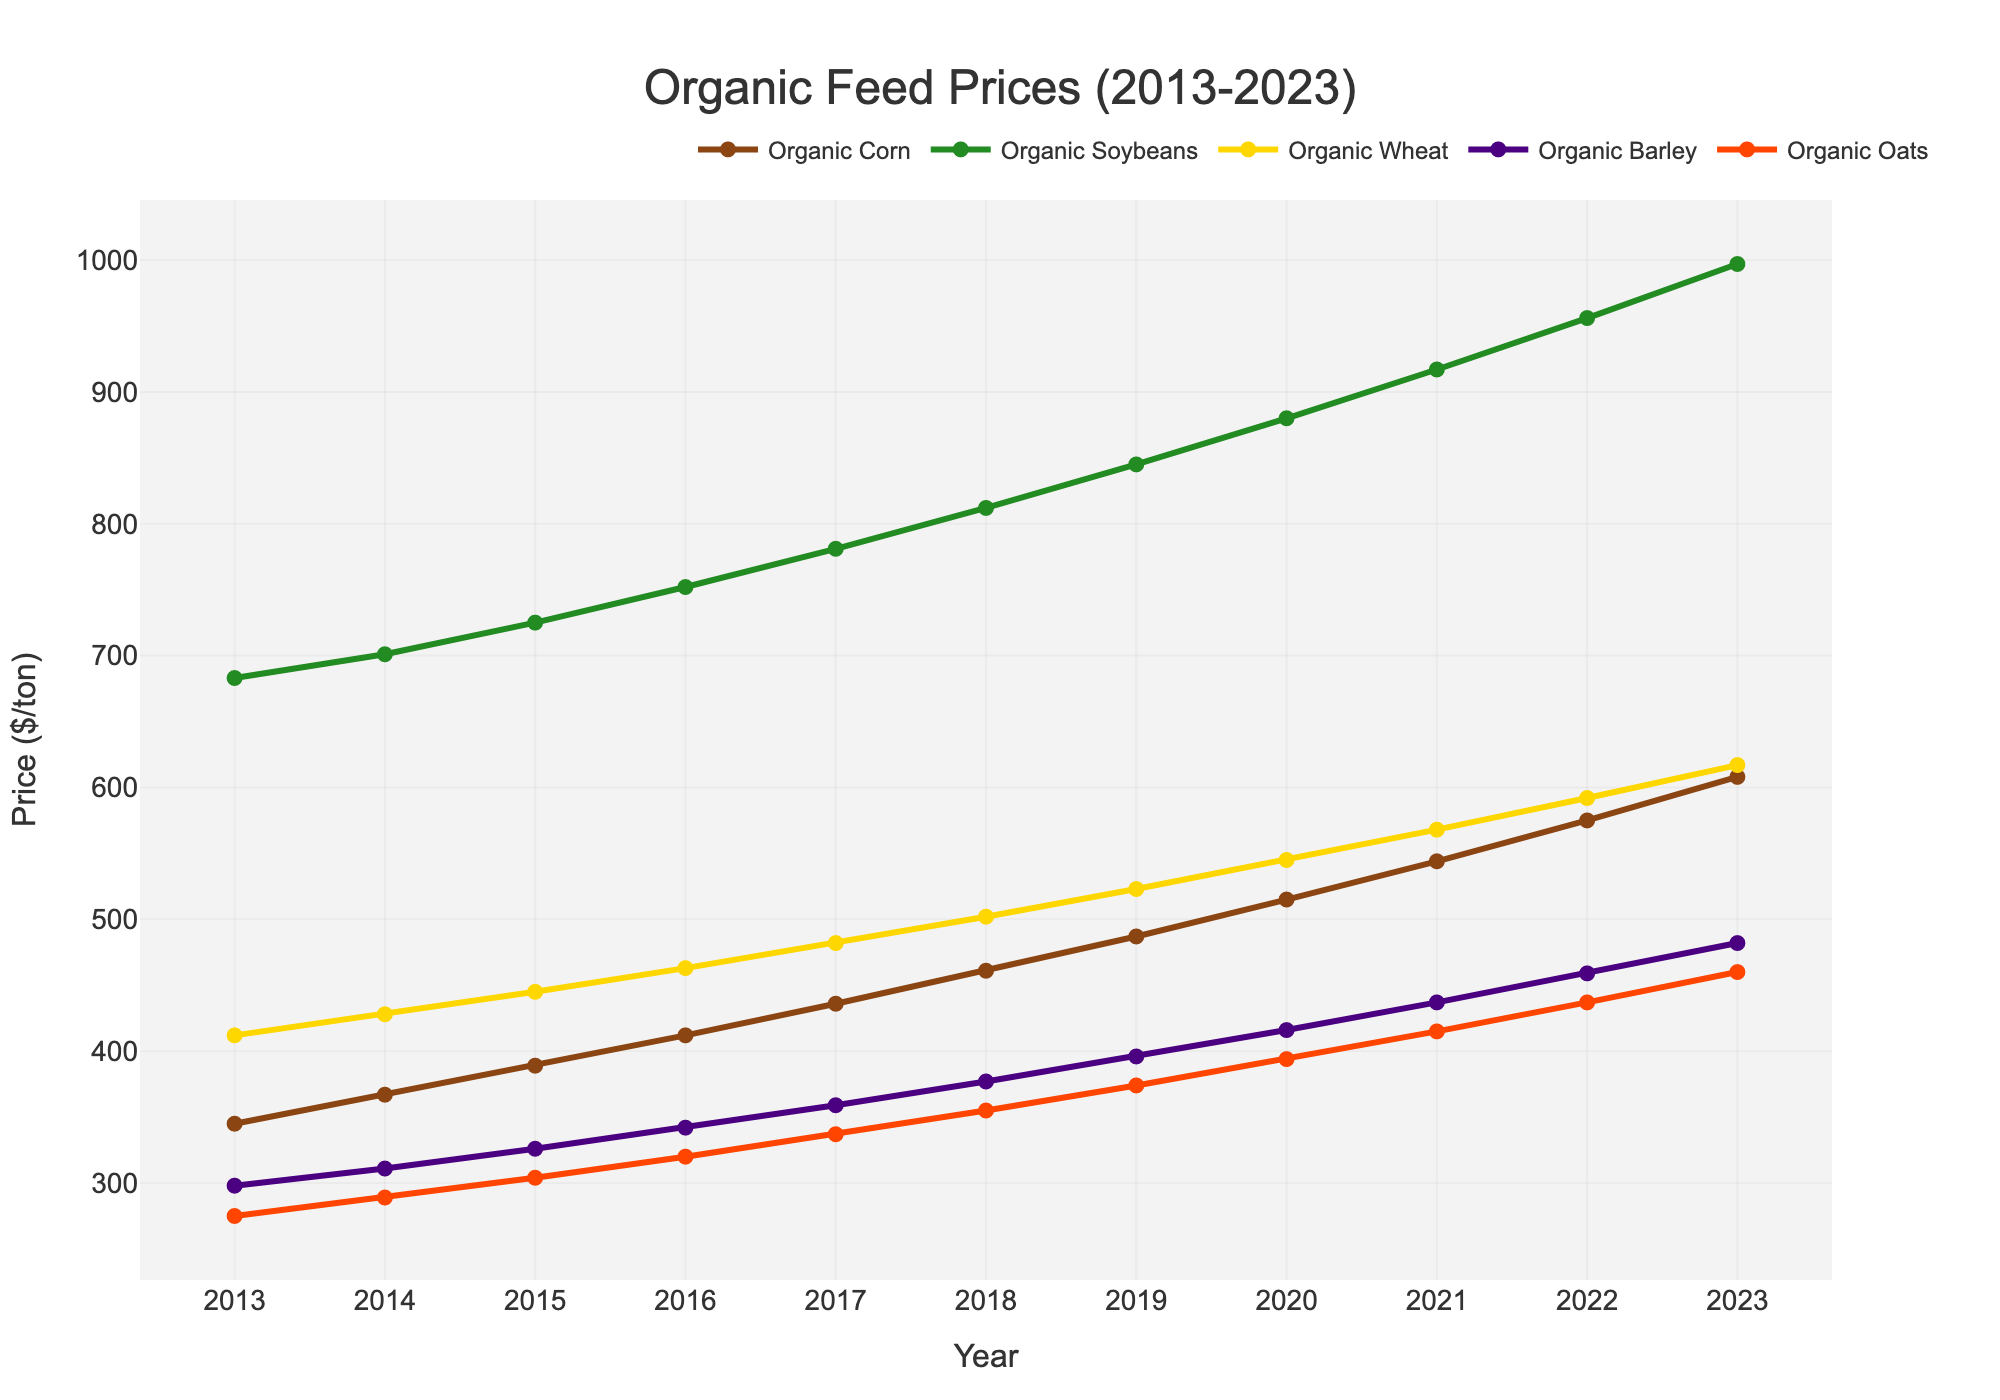What's the trend in Organic Corn prices from 2013 to 2023? To find the trend, observe the line representing Organic Corn. It starts at $345 in 2013 and steadily increases each year, reaching $608 in 2023. Thus, the trend shows a consistent rise in prices.
Answer: Consistent rise Which grain had the highest price in 2023? Look at the values for each grain in 2023: Organic Corn ($608), Organic Soybeans ($997), Organic Wheat ($617), Organic Barley ($482), and Organic Oats ($460). Organic Soybeans have the highest price at $997.
Answer: Organic Soybeans Calculate the average price of Organic Wheat from 2018 to 2023. Take the values of Organic Wheat from 2018 to 2023: 502, 523, 545, 568, 592, 617. Sum these values: 502 + 523 + 545 + 568 + 592 + 617 = 3347. Divide by the number of years, which is 6. So, the average price = 3347 / 6 ≈ 558.
Answer: 558 Which grain showed the highest increase in price from 2013 to 2023? Subtract the 2013 price from the 2023 price for each grain:
Organic Corn: 608 - 345 = 263
Organic Soybeans: 997 - 683 = 314
Organic Wheat: 617 - 412 = 205
Organic Barley: 482 - 298 = 184
Organic Oats: 460 - 275 = 185
Organic Soybeans had the highest increase with $314.
Answer: Organic Soybeans Which grain had the smallest price increase from 2013 to 2023? Subtract the 2013 price from the 2023 price for each grain, as calculated previously. The smallest increase is for Organic Barley with $184.
Answer: Organic Barley In which year did Organic Soybeans surpass $800? Observe the trend line for Organic Soybeans. In 2018, the price reaches $812, crossing the $800 mark for the first time.
Answer: 2018 Compare the price trends of Organic Barley and Organic Oats between 2015 and 2020. Between 2015 and 2020, Organic Barley prices increased from $326 to $416, and Organic Oats prices increased from $304 to $394. Both grains followed an increasing trend, with Organic Barley showing a more gradual rise compared to Organic Oats.
Answer: Similar increasing trend, Barley more gradual What was the price difference between Organic Corn and Organic Wheat in 2021? Look at the prices in 2021: Organic Corn ($544) and Organic Wheat ($568). The difference is calculated as 568 - 544 = $24.
Answer: $24 Identify the grain with the most stable (least variable) price trend from 2013 to 2023. To determine stability, observe the trend lines. Organic Oats show the smallest annual increases and a steadier line compared to others, indicating it is the most stable.
Answer: Organic Oats 